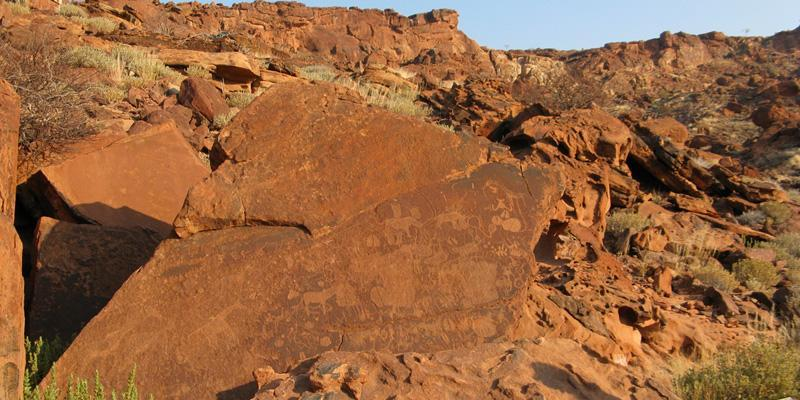How does the physical context of the arid environment affect the preservation of these rock engravings? The arid environment of Twyfelfontein actually aids in the preservation of these rock engravings. Low moisture levels mean less weathering and erosion caused by water, while the stable geological conditions help maintain the integrity of the rock surfaces. However, the extreme temperatures and occasional sand storms could pose a risk by causing surface abrasion over extended periods. 